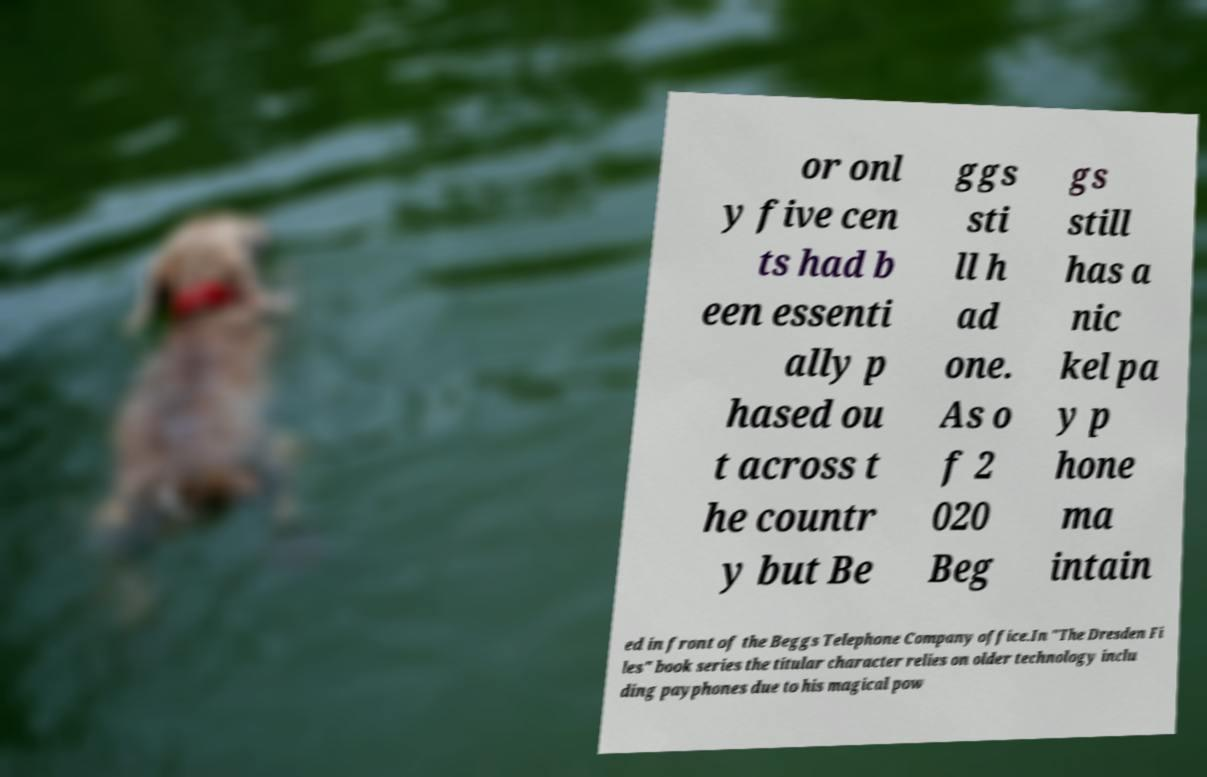Please identify and transcribe the text found in this image. or onl y five cen ts had b een essenti ally p hased ou t across t he countr y but Be ggs sti ll h ad one. As o f 2 020 Beg gs still has a nic kel pa y p hone ma intain ed in front of the Beggs Telephone Company office.In "The Dresden Fi les" book series the titular character relies on older technology inclu ding payphones due to his magical pow 